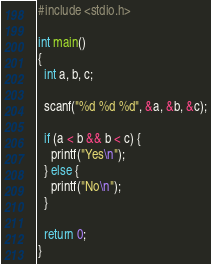<code> <loc_0><loc_0><loc_500><loc_500><_C_>#include <stdio.h>

int main()
{
  int a, b, c;

  scanf("%d %d %d", &a, &b, &c);

  if (a < b && b < c) {
    printf("Yes\n");
  } else {
    printf("No\n");
  }

  return 0;
}

</code> 